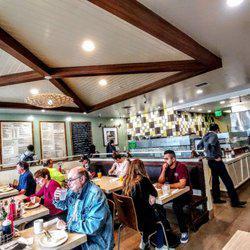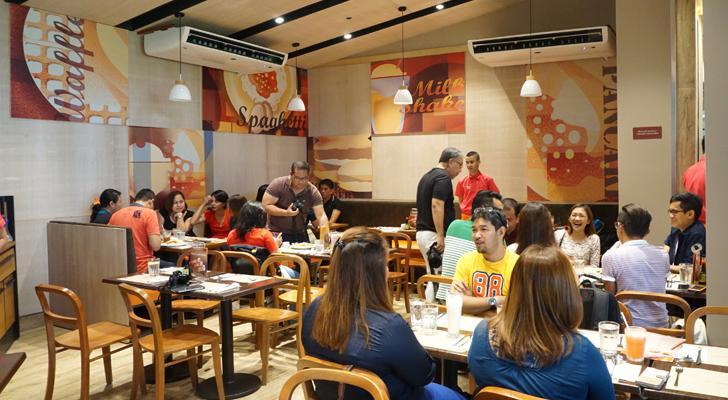The first image is the image on the left, the second image is the image on the right. Evaluate the accuracy of this statement regarding the images: "Someone is reading the menu board.". Is it true? Answer yes or no. Yes. The first image is the image on the left, the second image is the image on the right. For the images shown, is this caption "At least one of the images includes stained wooden beams on the ceiling." true? Answer yes or no. Yes. 